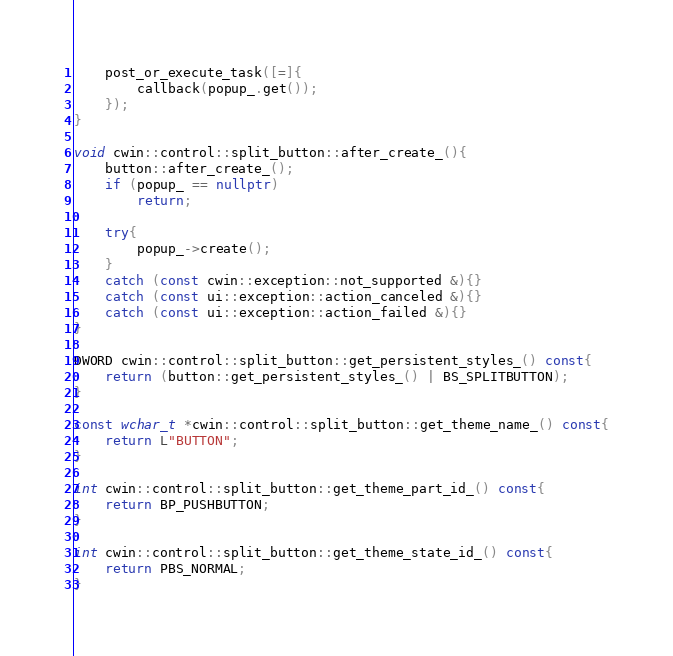<code> <loc_0><loc_0><loc_500><loc_500><_C++_>	post_or_execute_task([=]{
		callback(popup_.get());
	});
}

void cwin::control::split_button::after_create_(){
	button::after_create_();
	if (popup_ == nullptr)
		return;

	try{
		popup_->create();
	}
	catch (const cwin::exception::not_supported &){}
	catch (const ui::exception::action_canceled &){}
	catch (const ui::exception::action_failed &){}
}

DWORD cwin::control::split_button::get_persistent_styles_() const{
	return (button::get_persistent_styles_() | BS_SPLITBUTTON);
}

const wchar_t *cwin::control::split_button::get_theme_name_() const{
	return L"BUTTON";
}

int cwin::control::split_button::get_theme_part_id_() const{
	return BP_PUSHBUTTON;
}

int cwin::control::split_button::get_theme_state_id_() const{
	return PBS_NORMAL;
}
</code> 